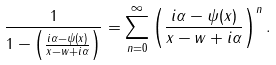Convert formula to latex. <formula><loc_0><loc_0><loc_500><loc_500>\frac { 1 } { 1 - \left ( \frac { i \alpha - \psi ( x ) } { x - w + i \alpha } \right ) } = \sum _ { n = 0 } ^ { \infty } \left ( \frac { i \alpha - \psi ( x ) } { x - w + i \alpha } \right ) ^ { n } .</formula> 